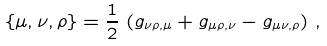<formula> <loc_0><loc_0><loc_500><loc_500>\{ \mu , \nu , \rho \} = \frac { 1 } { 2 } \, \left ( g _ { \nu \rho , \mu } + g _ { \mu \rho , \nu } - g _ { \mu \nu , \rho } \right ) \, ,</formula> 